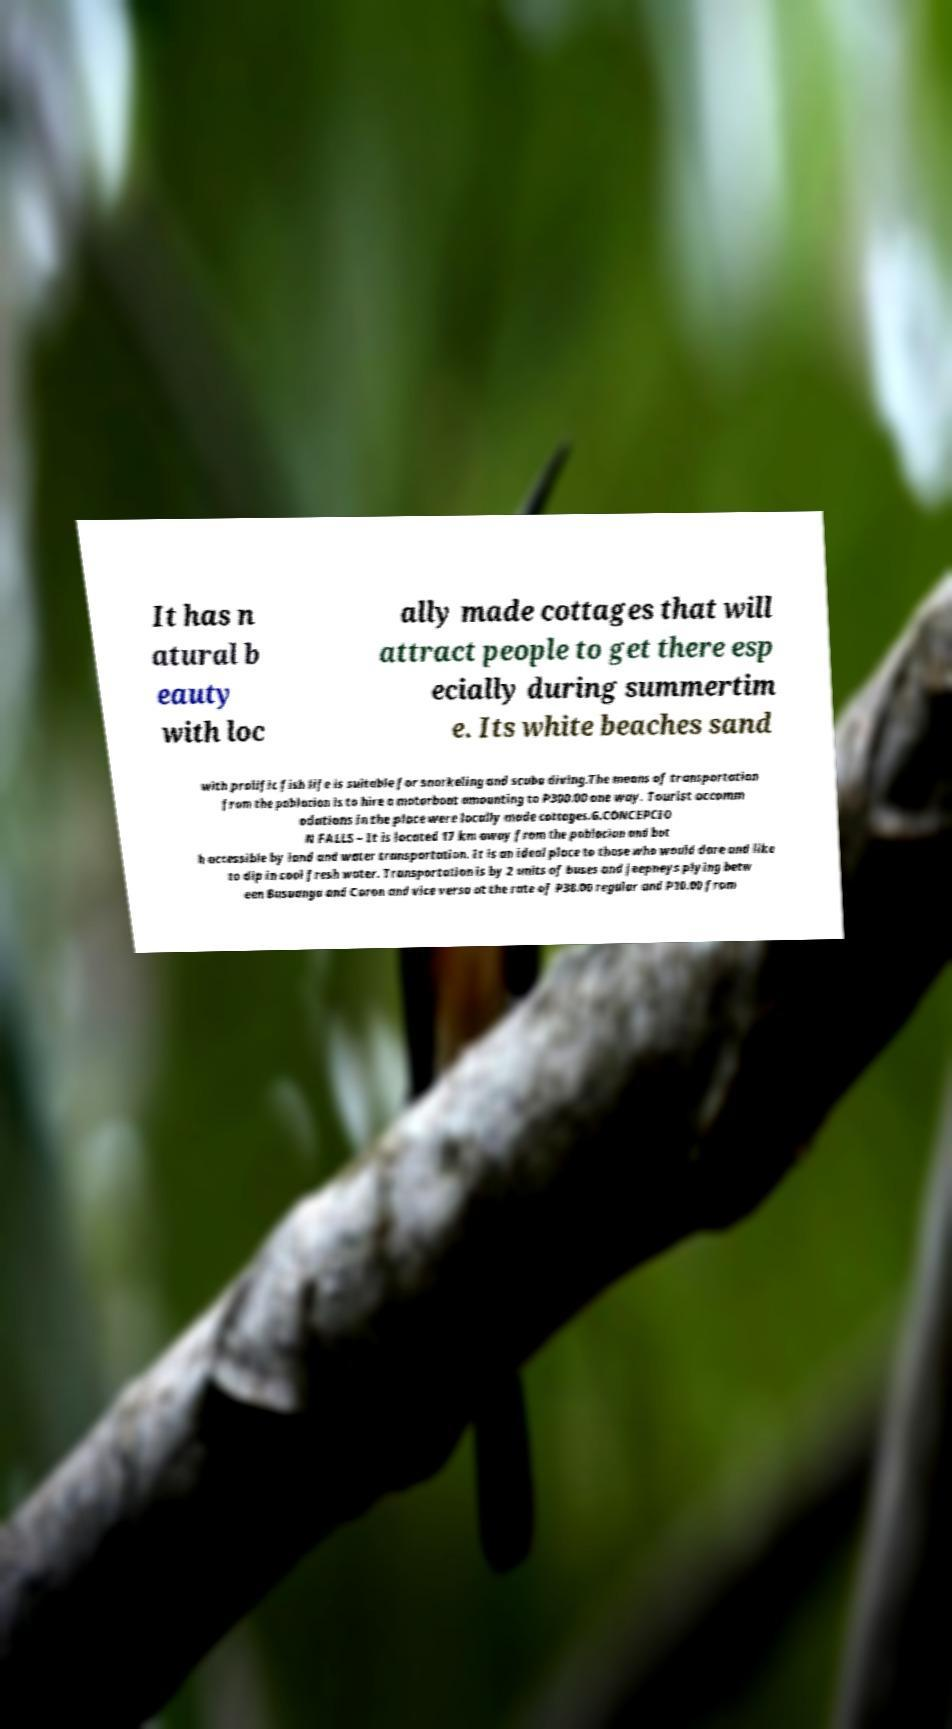For documentation purposes, I need the text within this image transcribed. Could you provide that? It has n atural b eauty with loc ally made cottages that will attract people to get there esp ecially during summertim e. Its white beaches sand with prolific fish life is suitable for snorkeling and scuba diving.The means of transportation from the poblacion is to hire a motorboat amounting to P300.00 one way. Tourist accomm odations in the place were locally made cottages.G.CONCEPCIO N FALLS – It is located 17 km away from the poblacion and bot h accessible by land and water transportation. It is an ideal place to those who would dare and like to dip in cool fresh water. Transportation is by 2 units of buses and jeepneys plying betw een Busuanga and Coron and vice versa at the rate of P38.00 regular and P10.00 from 